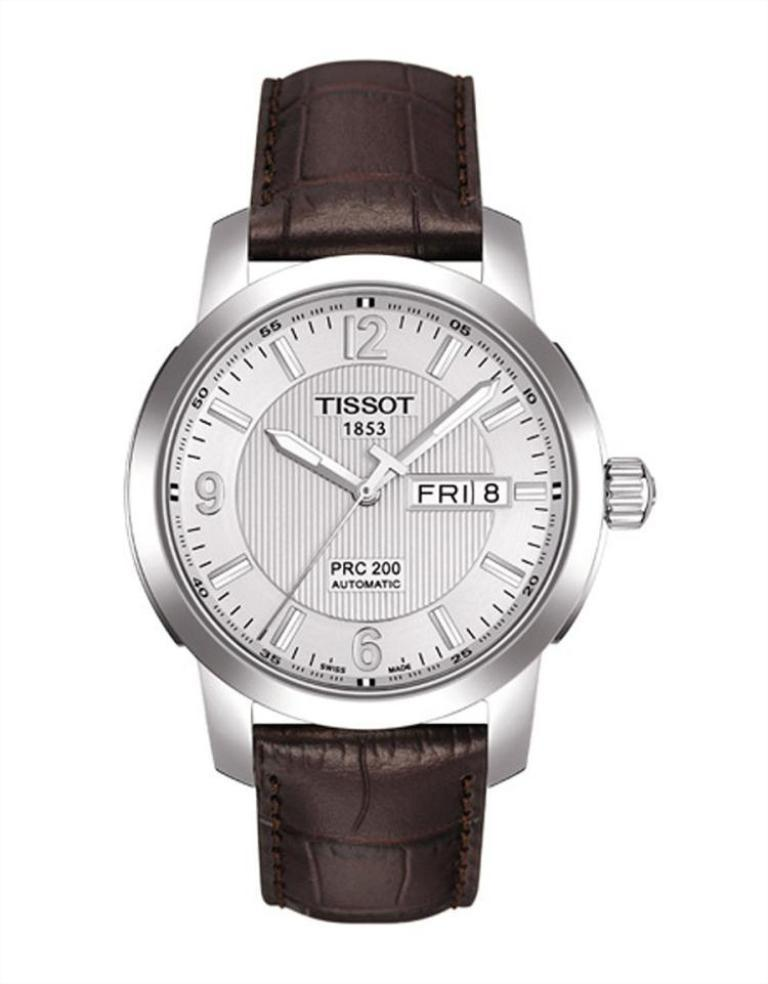<image>
Render a clear and concise summary of the photo. Silver and brown wrist watch which says TISSOT on the top. 